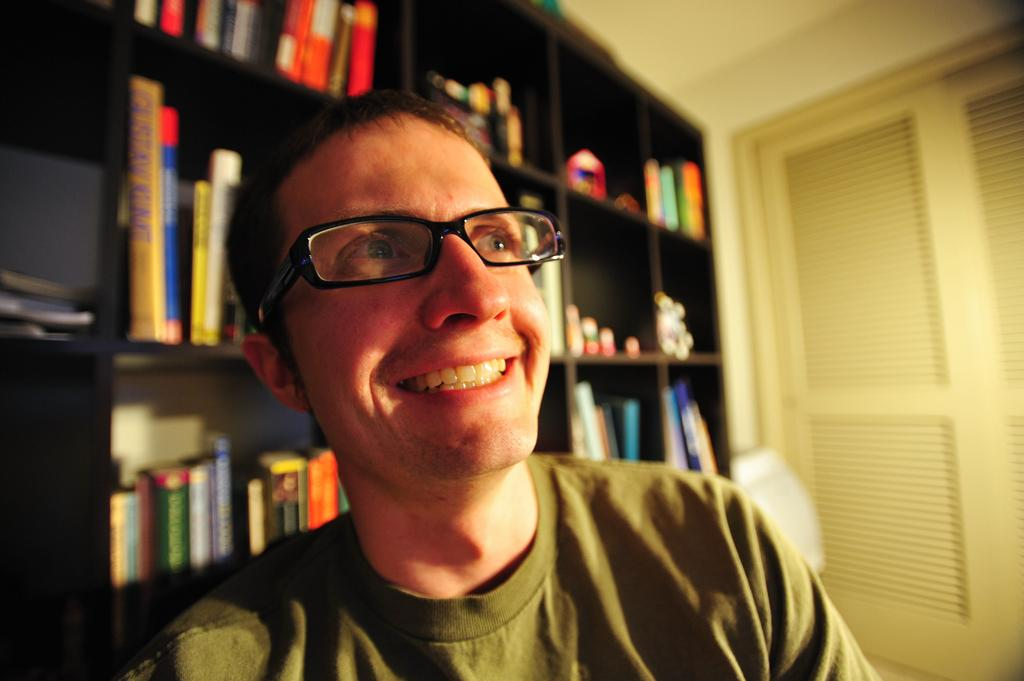Who is present in the image? There is a man in the image. Where is the man located in the image? The man is at the bottom of the image. What can be seen in the background of the image? There are books arranged in racks in the background. What architectural feature is visible on the right side of the image? There is a door on the right side of the image. What type of sweater is the man's sister wearing in the image? There is no mention of a sister or a sweater in the image, so we cannot answer this question. 